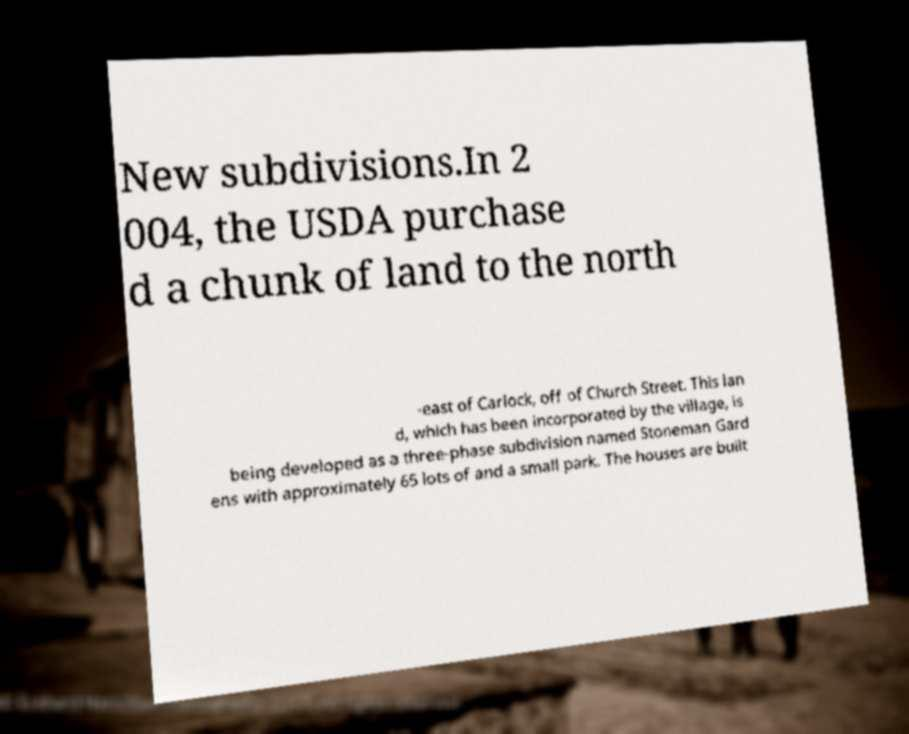What messages or text are displayed in this image? I need them in a readable, typed format. New subdivisions.In 2 004, the USDA purchase d a chunk of land to the north -east of Carlock, off of Church Street. This lan d, which has been incorporated by the village, is being developed as a three-phase subdivision named Stoneman Gard ens with approximately 65 lots of and a small park. The houses are built 